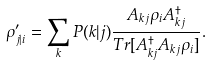Convert formula to latex. <formula><loc_0><loc_0><loc_500><loc_500>\rho ^ { \prime } _ { j | i } = \sum _ { k } P ( k | j ) \frac { A _ { k j } \rho _ { i } A _ { k j } ^ { \dagger } } { T r [ A _ { k j } ^ { \dagger } A _ { k j } \rho _ { i } ] } .</formula> 